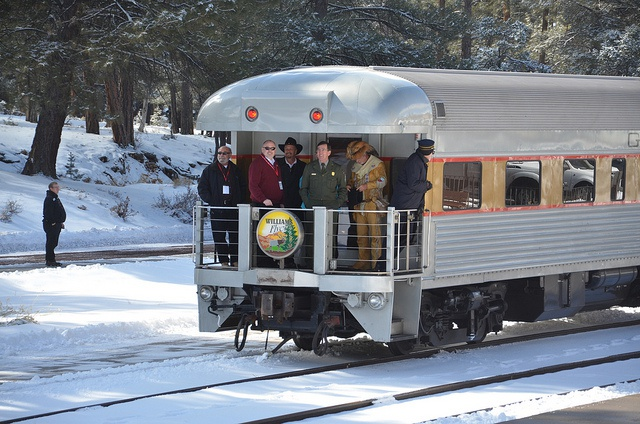Describe the objects in this image and their specific colors. I can see train in black, darkgray, gray, and lightgray tones, people in black, maroon, and gray tones, people in black, gray, and darkgray tones, people in black, gray, and darkgray tones, and people in black and gray tones in this image. 